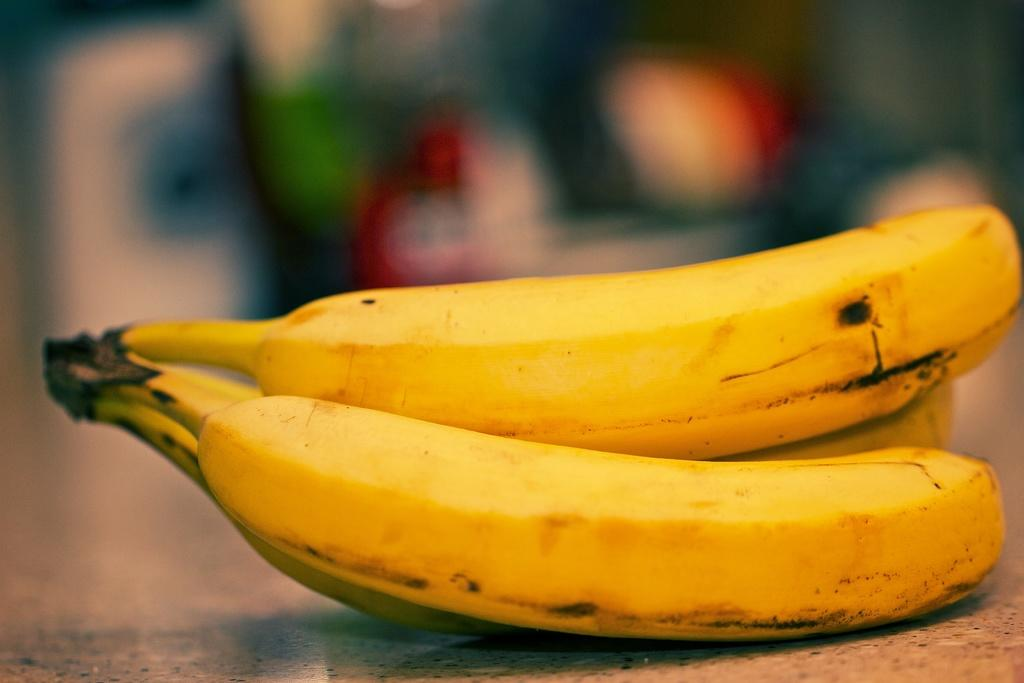What is on the floor in the image? There are bananas on the floor in the image. Can you describe the background of the image? The background of the image is blurred. How many friends are playing the guitar in the image? There are no friends or guitars present in the image; it only features bananas on the floor and a blurred background. 